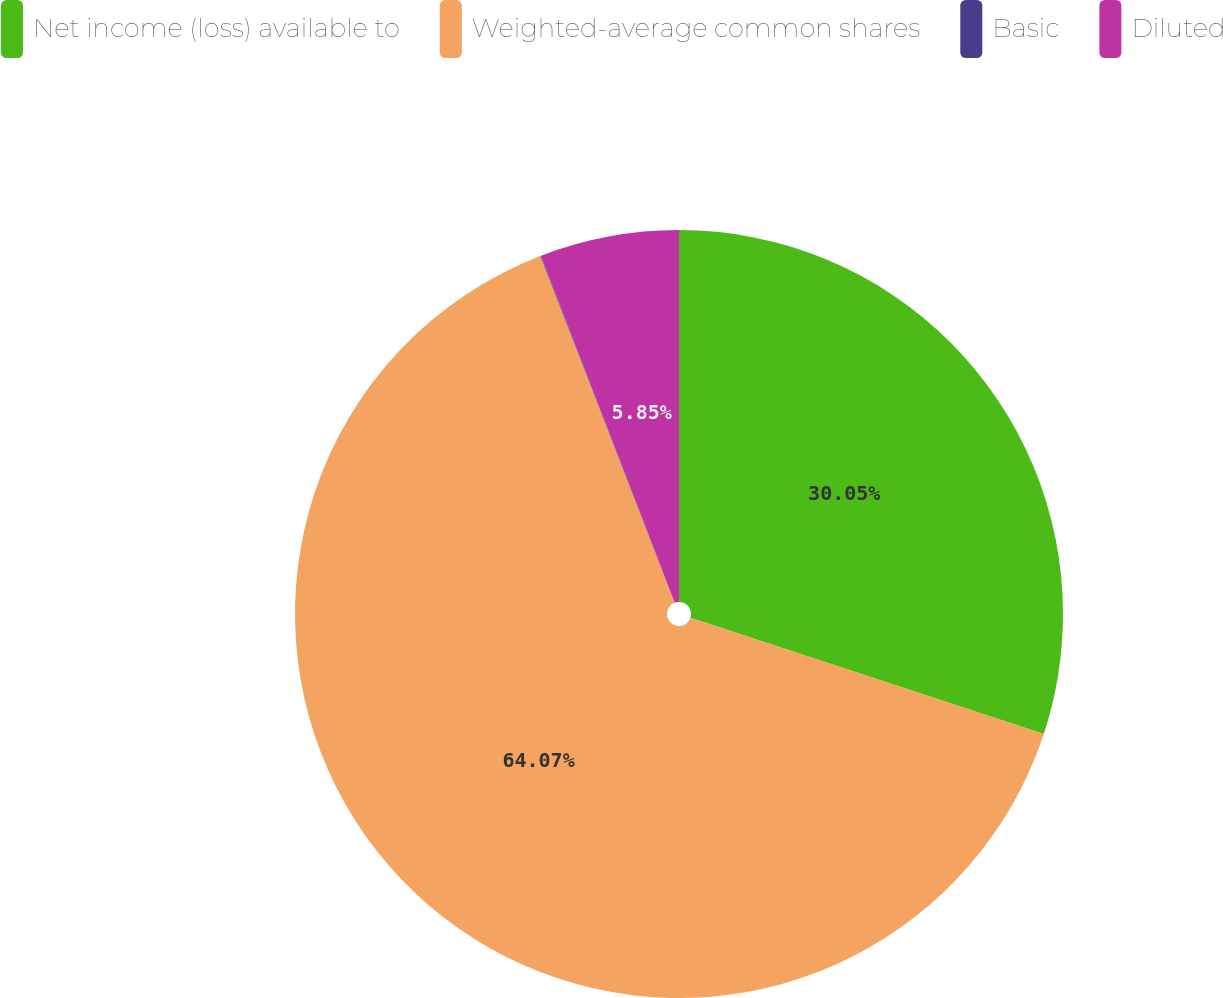<chart> <loc_0><loc_0><loc_500><loc_500><pie_chart><fcel>Net income (loss) available to<fcel>Weighted-average common shares<fcel>Basic<fcel>Diluted<nl><fcel>30.05%<fcel>64.06%<fcel>0.03%<fcel>5.85%<nl></chart> 